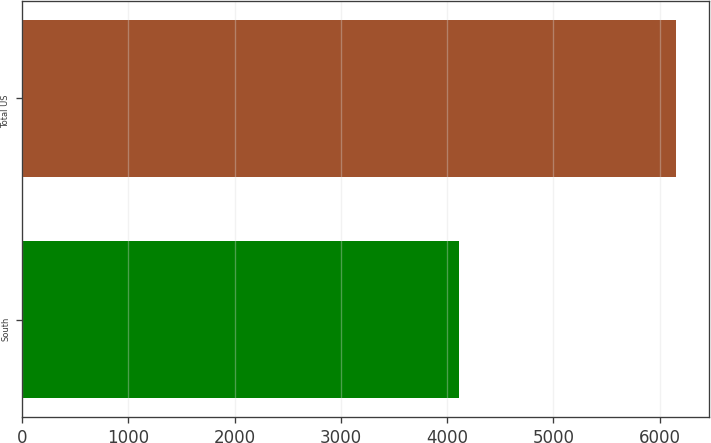Convert chart to OTSL. <chart><loc_0><loc_0><loc_500><loc_500><bar_chart><fcel>South<fcel>Total US<nl><fcel>4115<fcel>6153<nl></chart> 